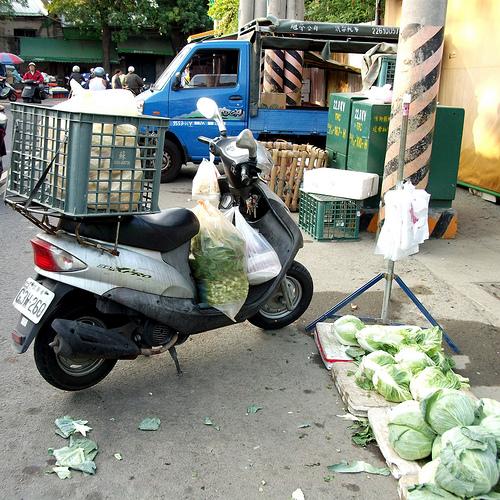What is the bike carrying?
Answer briefly. Food. What are those vegetables on the ground?
Write a very short answer. Cabbage. What color is the truck?
Answer briefly. Blue. 